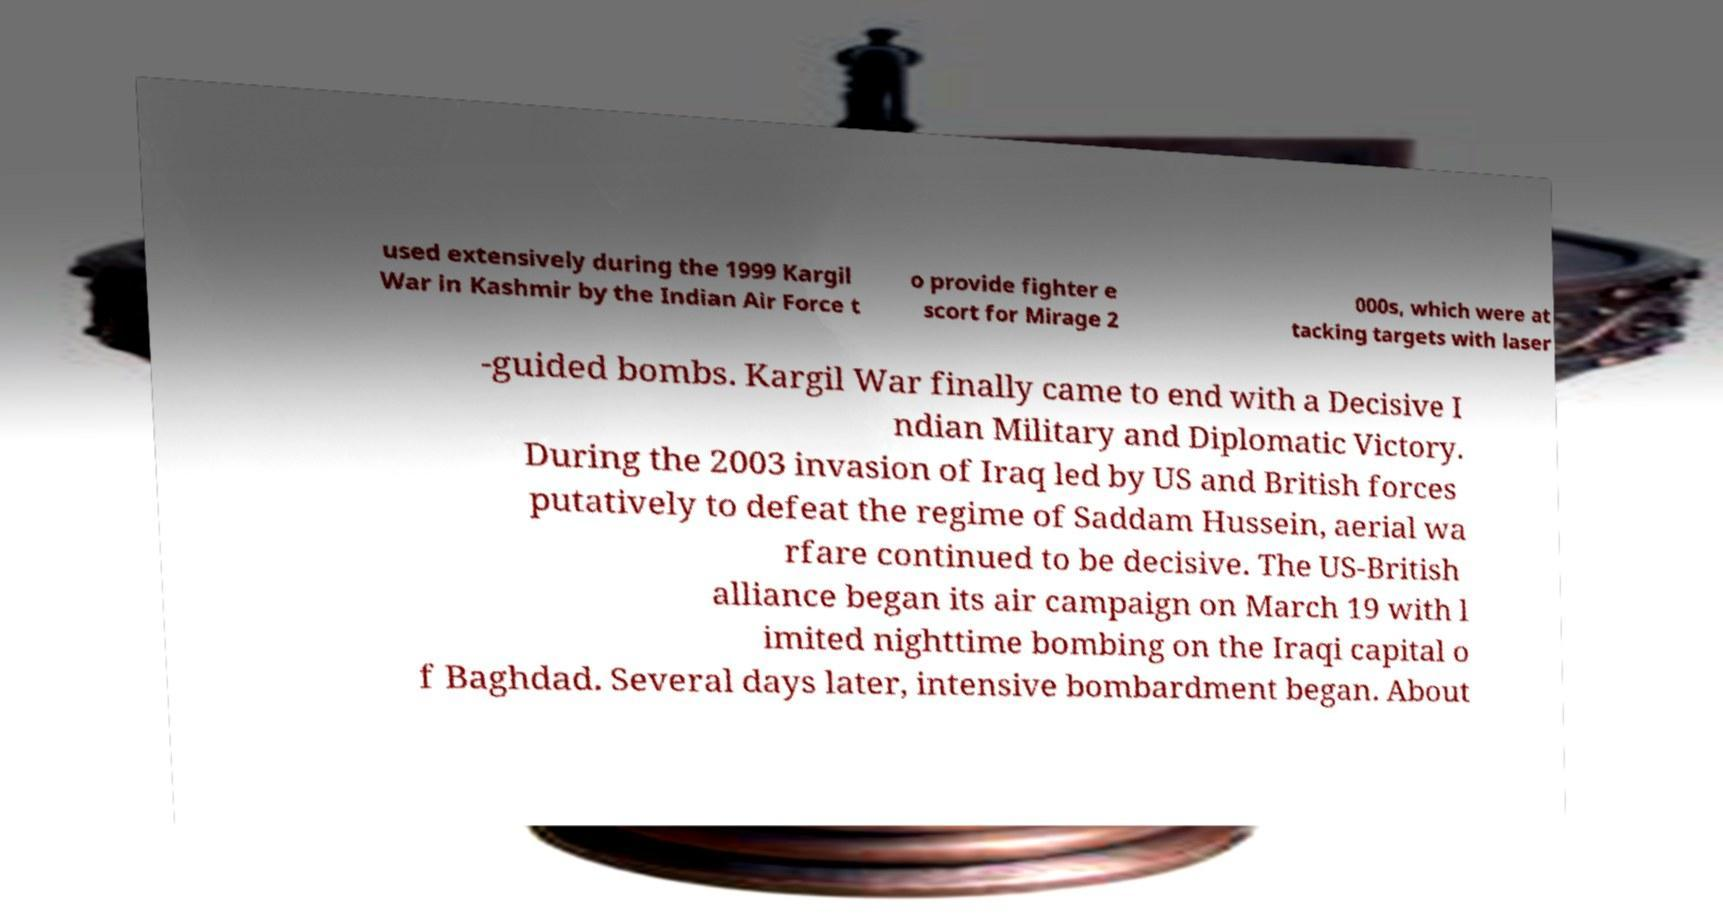Please identify and transcribe the text found in this image. used extensively during the 1999 Kargil War in Kashmir by the Indian Air Force t o provide fighter e scort for Mirage 2 000s, which were at tacking targets with laser -guided bombs. Kargil War finally came to end with a Decisive I ndian Military and Diplomatic Victory. During the 2003 invasion of Iraq led by US and British forces putatively to defeat the regime of Saddam Hussein, aerial wa rfare continued to be decisive. The US-British alliance began its air campaign on March 19 with l imited nighttime bombing on the Iraqi capital o f Baghdad. Several days later, intensive bombardment began. About 